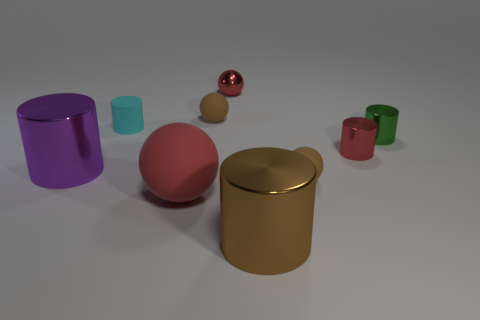Add 1 small objects. How many objects exist? 10 Subtract all red balls. How many balls are left? 2 Subtract all large purple cylinders. How many cylinders are left? 4 How many red spheres must be subtracted to get 1 red spheres? 1 Subtract all spheres. How many objects are left? 5 Subtract 1 spheres. How many spheres are left? 3 Subtract all cyan spheres. Subtract all blue cylinders. How many spheres are left? 4 Subtract all blue spheres. How many purple cylinders are left? 1 Subtract all cyan rubber cubes. Subtract all cylinders. How many objects are left? 4 Add 2 small cylinders. How many small cylinders are left? 5 